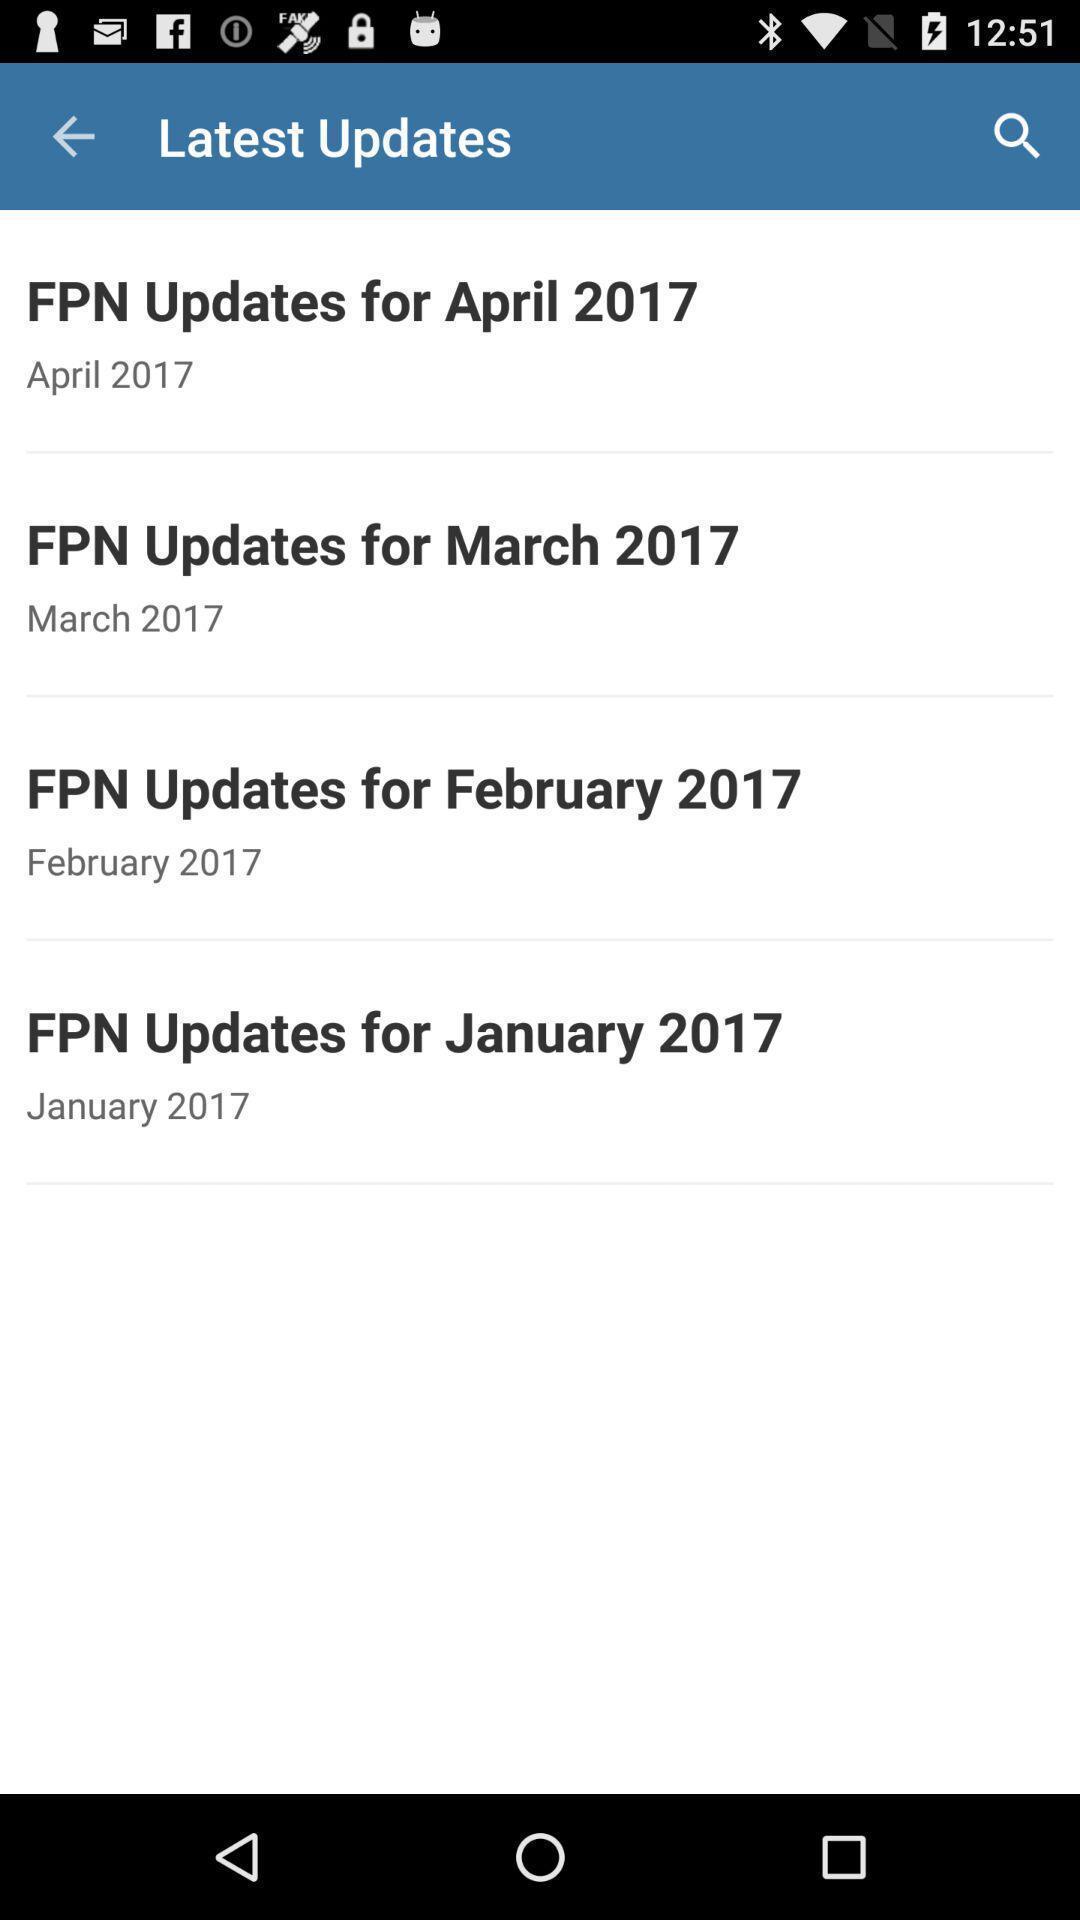Provide a textual representation of this image. Page showing latest fpn updates. 